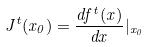Convert formula to latex. <formula><loc_0><loc_0><loc_500><loc_500>J ^ { t } ( x _ { 0 } ) = \frac { d f ^ { t } ( x ) } { d x } | _ { x _ { 0 } }</formula> 